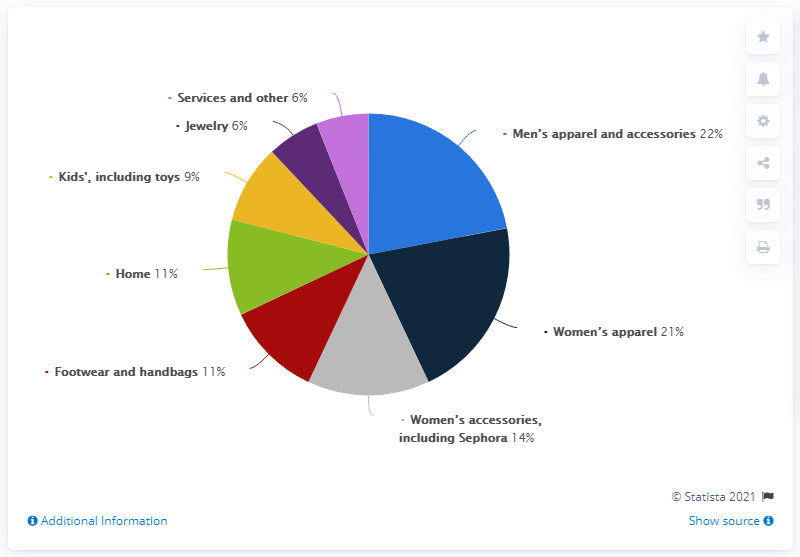Draw attention to some important aspects in this diagram. The average of all product categories is greater than the median, according to the provided data. What is the most frequently occurring value in the colored segments of [6, 11]? 